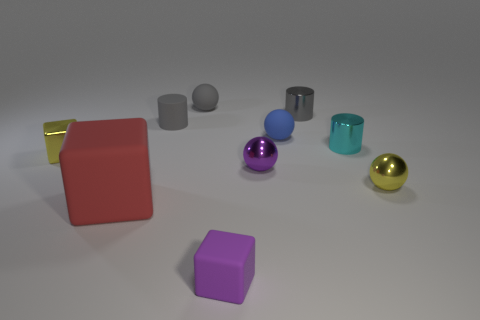Subtract all gray cylinders. How many cylinders are left? 1 Subtract all purple balls. How many balls are left? 3 Subtract all green balls. Subtract all yellow cylinders. How many balls are left? 4 Subtract all cylinders. How many objects are left? 7 Add 5 blue matte spheres. How many blue matte spheres exist? 6 Subtract 0 cyan balls. How many objects are left? 10 Subtract all cylinders. Subtract all purple objects. How many objects are left? 5 Add 5 small matte balls. How many small matte balls are left? 7 